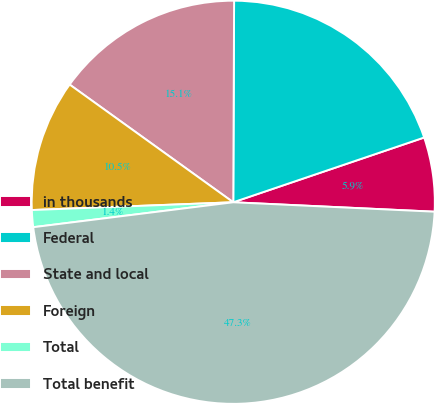Convert chart to OTSL. <chart><loc_0><loc_0><loc_500><loc_500><pie_chart><fcel>in thousands<fcel>Federal<fcel>State and local<fcel>Foreign<fcel>Total<fcel>Total benefit<nl><fcel>5.95%<fcel>19.73%<fcel>15.14%<fcel>10.54%<fcel>1.36%<fcel>47.28%<nl></chart> 